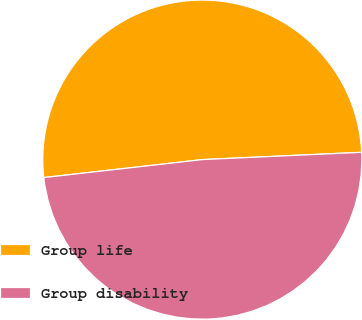<chart> <loc_0><loc_0><loc_500><loc_500><pie_chart><fcel>Group life<fcel>Group disability<nl><fcel>51.07%<fcel>48.93%<nl></chart> 